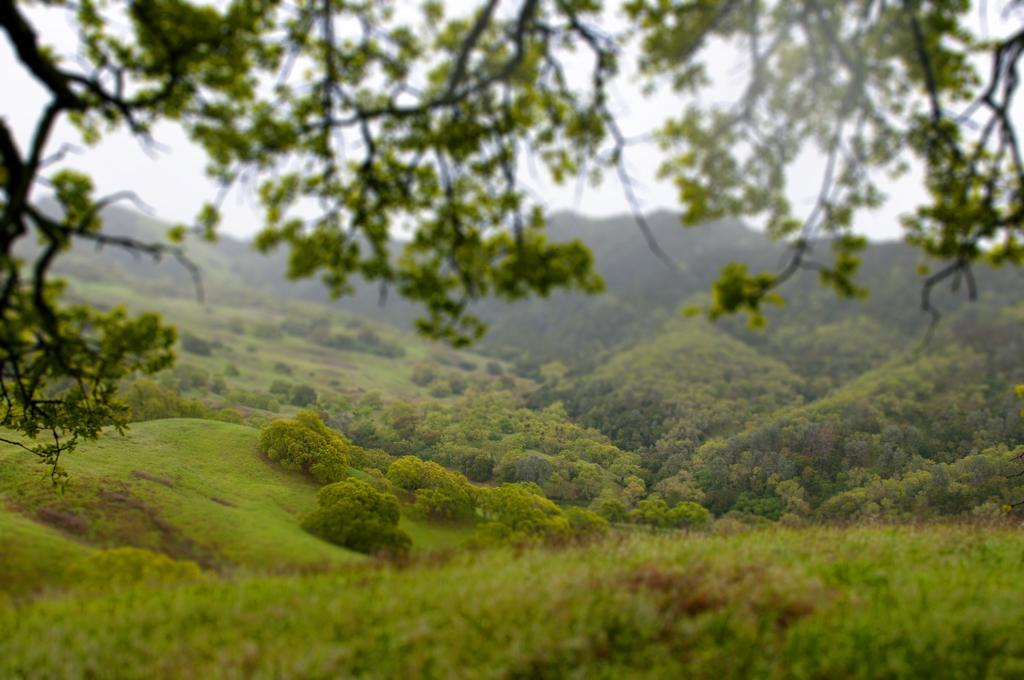Can you describe this image briefly? In this image, I can see the trees with branches and leaves. I think these are the hills. At the bottom of the image, I think this is the grass, which is green in color. 